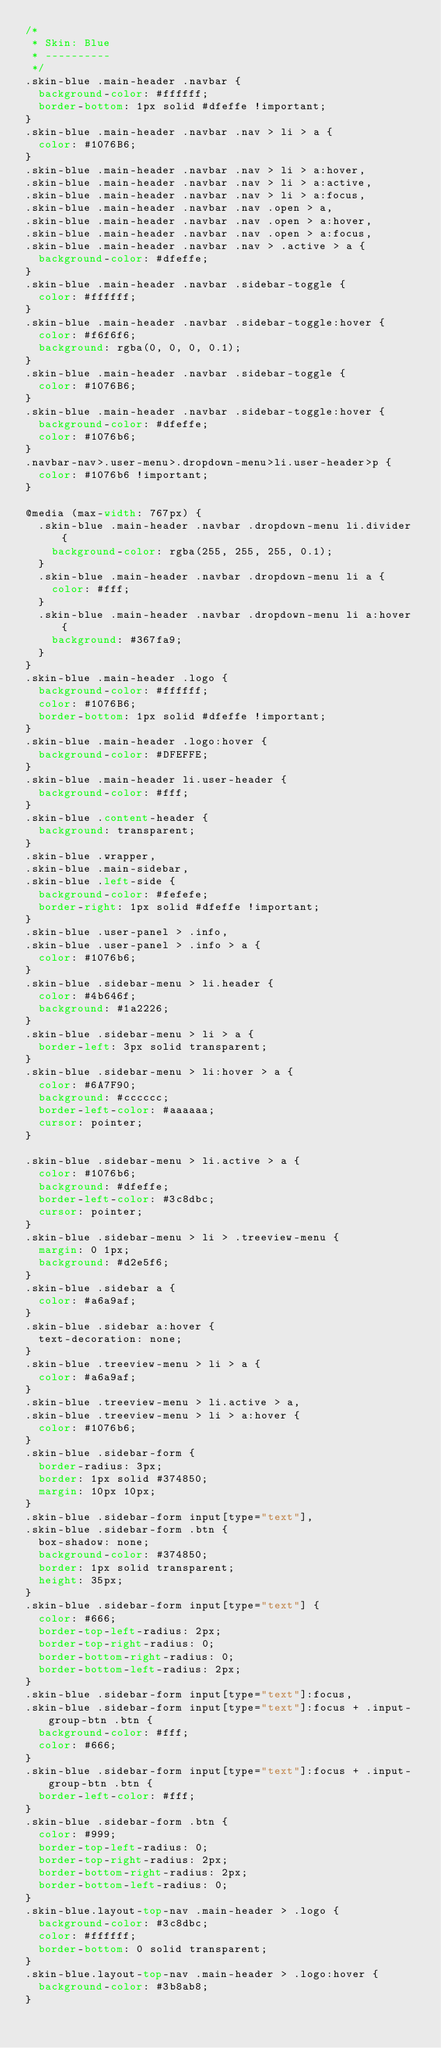Convert code to text. <code><loc_0><loc_0><loc_500><loc_500><_CSS_>/*
 * Skin: Blue
 * ----------
 */
.skin-blue .main-header .navbar {
  background-color: #ffffff;
  border-bottom: 1px solid #dfeffe !important;
}
.skin-blue .main-header .navbar .nav > li > a {
  color: #1076B6;
}
.skin-blue .main-header .navbar .nav > li > a:hover,
.skin-blue .main-header .navbar .nav > li > a:active,
.skin-blue .main-header .navbar .nav > li > a:focus,
.skin-blue .main-header .navbar .nav .open > a,
.skin-blue .main-header .navbar .nav .open > a:hover,
.skin-blue .main-header .navbar .nav .open > a:focus,
.skin-blue .main-header .navbar .nav > .active > a {
  background-color: #dfeffe;
}
.skin-blue .main-header .navbar .sidebar-toggle {
  color: #ffffff;
}
.skin-blue .main-header .navbar .sidebar-toggle:hover {
  color: #f6f6f6;
  background: rgba(0, 0, 0, 0.1);
}
.skin-blue .main-header .navbar .sidebar-toggle {
  color: #1076B6;
}
.skin-blue .main-header .navbar .sidebar-toggle:hover {
  background-color: #dfeffe;
  color: #1076b6;
}
.navbar-nav>.user-menu>.dropdown-menu>li.user-header>p {
  color: #1076b6 !important;
}

@media (max-width: 767px) {
  .skin-blue .main-header .navbar .dropdown-menu li.divider {
    background-color: rgba(255, 255, 255, 0.1);
  }
  .skin-blue .main-header .navbar .dropdown-menu li a {
    color: #fff;
  }
  .skin-blue .main-header .navbar .dropdown-menu li a:hover {
    background: #367fa9;
  }
}
.skin-blue .main-header .logo {
  background-color: #ffffff;
  color: #1076B6;
  border-bottom: 1px solid #dfeffe !important;
}
.skin-blue .main-header .logo:hover {
  background-color: #DFEFFE;
}
.skin-blue .main-header li.user-header {
  background-color: #fff;
}
.skin-blue .content-header {
  background: transparent;
}
.skin-blue .wrapper,
.skin-blue .main-sidebar,
.skin-blue .left-side {
  background-color: #fefefe;
  border-right: 1px solid #dfeffe !important;
}
.skin-blue .user-panel > .info,
.skin-blue .user-panel > .info > a {
  color: #1076b6;
}
.skin-blue .sidebar-menu > li.header {
  color: #4b646f;
  background: #1a2226;
}
.skin-blue .sidebar-menu > li > a {
  border-left: 3px solid transparent;
}
.skin-blue .sidebar-menu > li:hover > a {
  color: #6A7F90;
  background: #cccccc;
  border-left-color: #aaaaaa;
  cursor: pointer;
}

.skin-blue .sidebar-menu > li.active > a {
  color: #1076b6;
  background: #dfeffe;
  border-left-color: #3c8dbc;
  cursor: pointer;
}
.skin-blue .sidebar-menu > li > .treeview-menu {
  margin: 0 1px;
  background: #d2e5f6;
}
.skin-blue .sidebar a {
  color: #a6a9af;
}
.skin-blue .sidebar a:hover {
  text-decoration: none;
}
.skin-blue .treeview-menu > li > a {
  color: #a6a9af;
}
.skin-blue .treeview-menu > li.active > a,
.skin-blue .treeview-menu > li > a:hover {
  color: #1076b6;
}
.skin-blue .sidebar-form {
  border-radius: 3px;
  border: 1px solid #374850;
  margin: 10px 10px;
}
.skin-blue .sidebar-form input[type="text"],
.skin-blue .sidebar-form .btn {
  box-shadow: none;
  background-color: #374850;
  border: 1px solid transparent;
  height: 35px;
}
.skin-blue .sidebar-form input[type="text"] {
  color: #666;
  border-top-left-radius: 2px;
  border-top-right-radius: 0;
  border-bottom-right-radius: 0;
  border-bottom-left-radius: 2px;
}
.skin-blue .sidebar-form input[type="text"]:focus,
.skin-blue .sidebar-form input[type="text"]:focus + .input-group-btn .btn {
  background-color: #fff;
  color: #666;
}
.skin-blue .sidebar-form input[type="text"]:focus + .input-group-btn .btn {
  border-left-color: #fff;
}
.skin-blue .sidebar-form .btn {
  color: #999;
  border-top-left-radius: 0;
  border-top-right-radius: 2px;
  border-bottom-right-radius: 2px;
  border-bottom-left-radius: 0;
}
.skin-blue.layout-top-nav .main-header > .logo {
  background-color: #3c8dbc;
  color: #ffffff;
  border-bottom: 0 solid transparent;
}
.skin-blue.layout-top-nav .main-header > .logo:hover {
  background-color: #3b8ab8;
}
</code> 